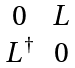Convert formula to latex. <formula><loc_0><loc_0><loc_500><loc_500>\begin{matrix} 0 & L \\ L ^ { \dagger } & 0 \end{matrix}</formula> 